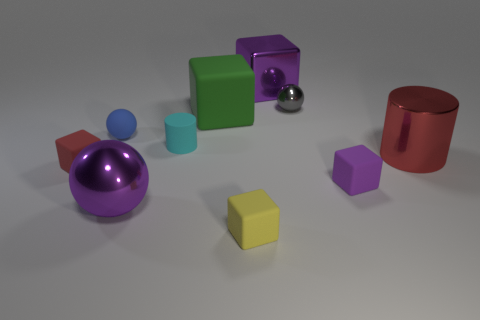Subtract all purple cubes. How many cubes are left? 3 Subtract 3 blocks. How many blocks are left? 2 Subtract all gray spheres. How many spheres are left? 2 Subtract all cylinders. How many objects are left? 8 Subtract all purple blocks. How many yellow cylinders are left? 0 Subtract all brown objects. Subtract all small shiny spheres. How many objects are left? 9 Add 7 large green matte blocks. How many large green matte blocks are left? 8 Add 5 small blue shiny blocks. How many small blue shiny blocks exist? 5 Subtract 0 cyan balls. How many objects are left? 10 Subtract all blue spheres. Subtract all purple cubes. How many spheres are left? 2 